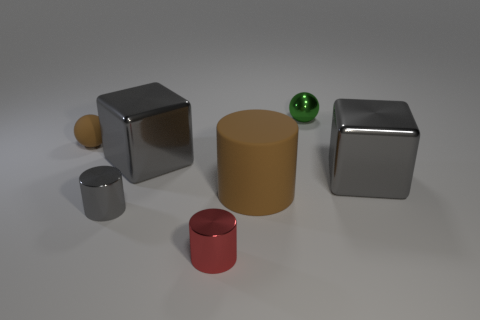How many other objects are there of the same material as the tiny gray cylinder?
Offer a very short reply. 4. Is there a tiny gray ball?
Provide a short and direct response. No. Are the tiny sphere on the right side of the small brown ball and the red cylinder made of the same material?
Your response must be concise. Yes. What material is the brown object that is the same shape as the tiny green thing?
Offer a terse response. Rubber. What is the material of the other thing that is the same color as the small matte object?
Keep it short and to the point. Rubber. Is the number of gray metallic objects less than the number of large gray shiny blocks?
Offer a terse response. No. There is a big cylinder in front of the tiny green ball; does it have the same color as the tiny matte ball?
Provide a short and direct response. Yes. There is another object that is the same material as the big brown thing; what color is it?
Give a very brief answer. Brown. Do the green metal thing and the red shiny cylinder have the same size?
Give a very brief answer. Yes. What is the large cylinder made of?
Offer a very short reply. Rubber. 